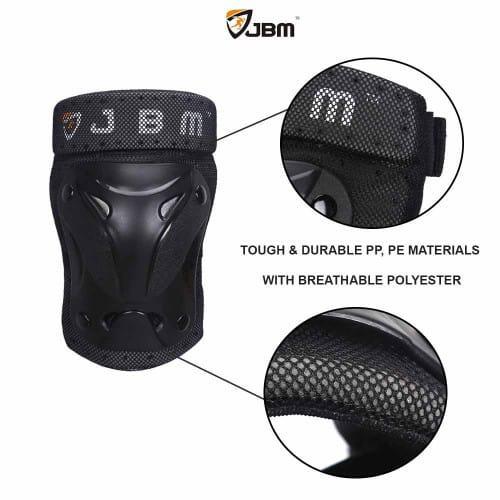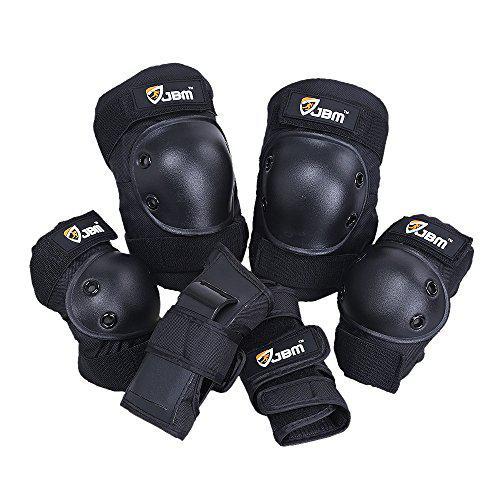The first image is the image on the left, the second image is the image on the right. Evaluate the accuracy of this statement regarding the images: "At least one image in the set contains exactly four kneepads, with no lettering on them or brand names.". Is it true? Answer yes or no. No. The first image is the image on the left, the second image is the image on the right. Examine the images to the left and right. Is the description "There are at least eight pieces of black gear featured." accurate? Answer yes or no. No. 